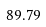<formula> <loc_0><loc_0><loc_500><loc_500>8 9 . 7 9</formula> 